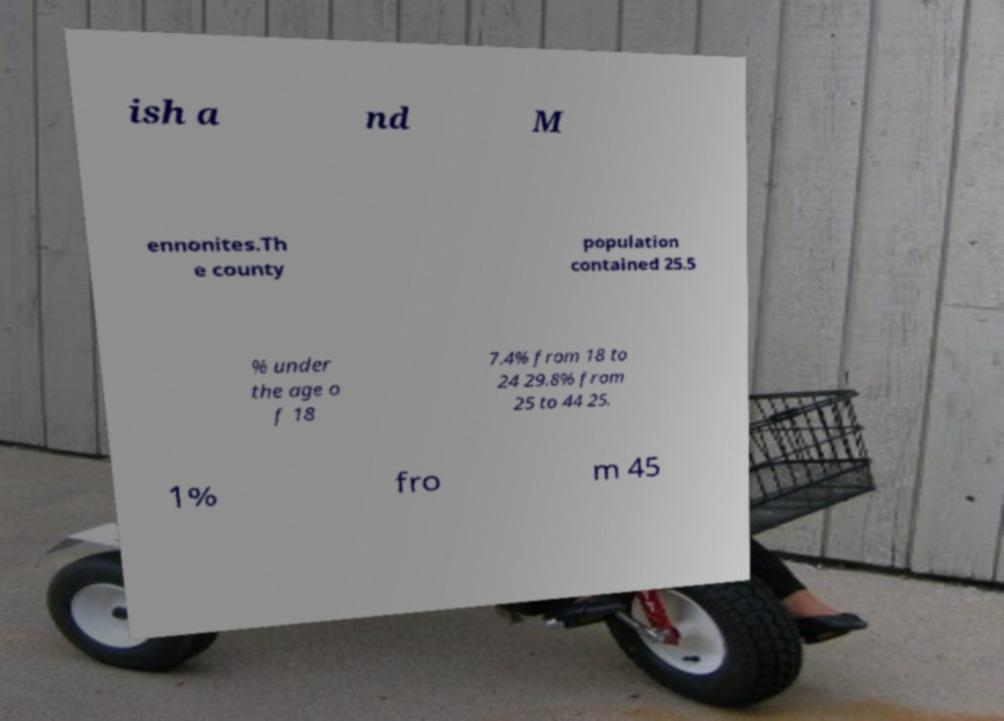Could you assist in decoding the text presented in this image and type it out clearly? ish a nd M ennonites.Th e county population contained 25.5 % under the age o f 18 7.4% from 18 to 24 29.8% from 25 to 44 25. 1% fro m 45 